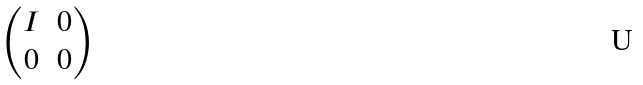Convert formula to latex. <formula><loc_0><loc_0><loc_500><loc_500>\begin{pmatrix} I & 0 \\ 0 & 0 \end{pmatrix}</formula> 